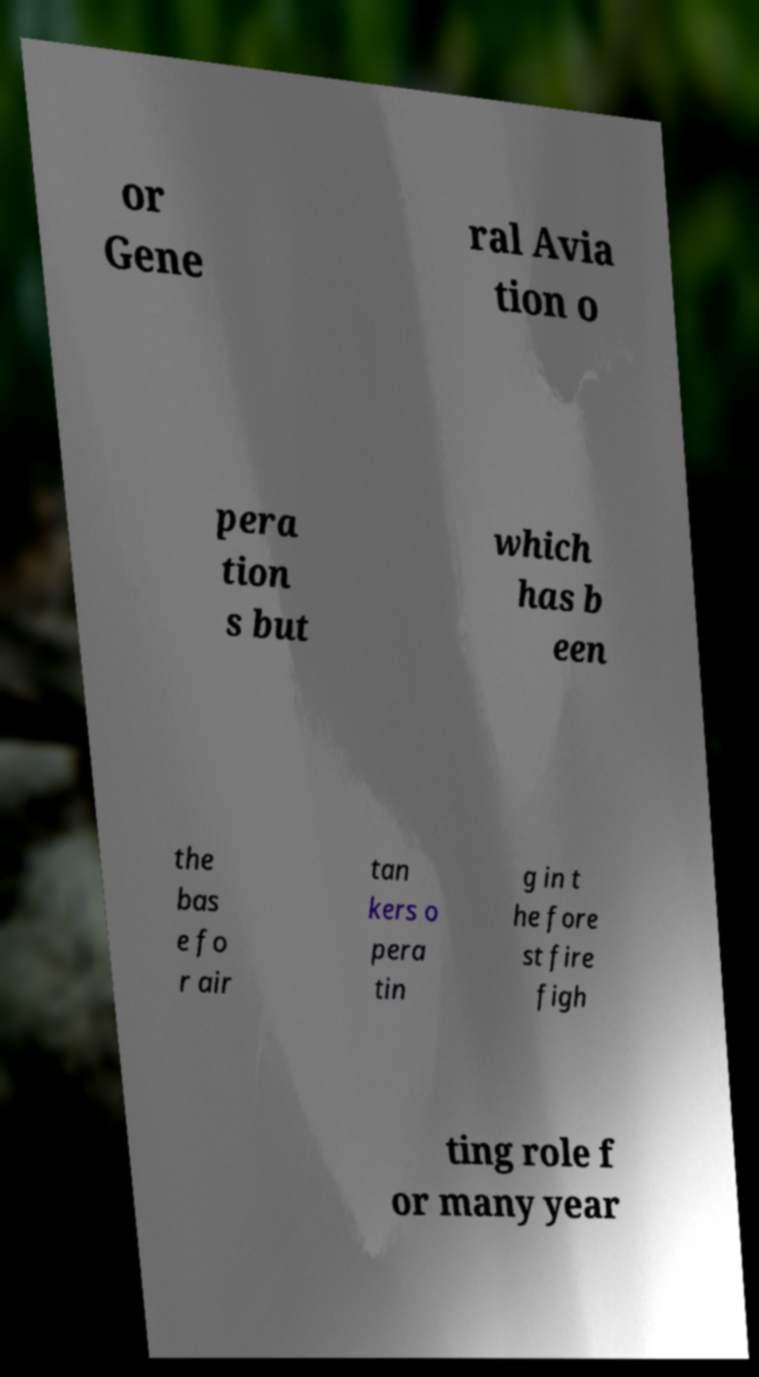What messages or text are displayed in this image? I need them in a readable, typed format. or Gene ral Avia tion o pera tion s but which has b een the bas e fo r air tan kers o pera tin g in t he fore st fire figh ting role f or many year 